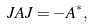<formula> <loc_0><loc_0><loc_500><loc_500>J A J = - A ^ { * } ,</formula> 